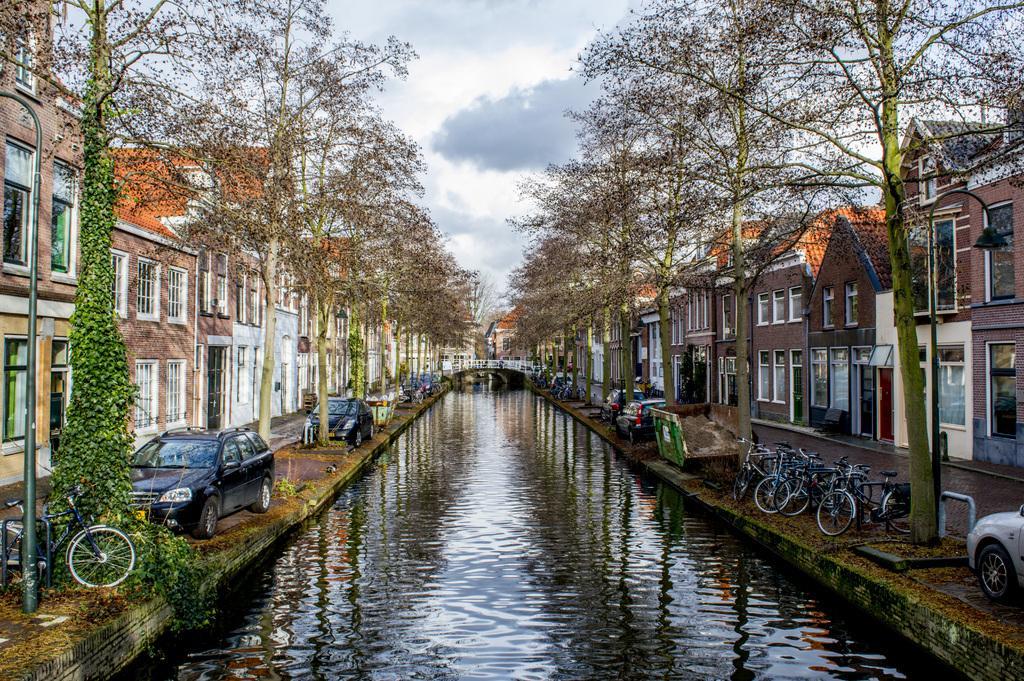Describe this image in one or two sentences. In this image there is a lake in the bottom of this image. There are some cars, bicycles, trees and some buildings on the left side of this image,and right side of this image. There is a bridge in the middle of this image. There is a sky on the top of this image. 